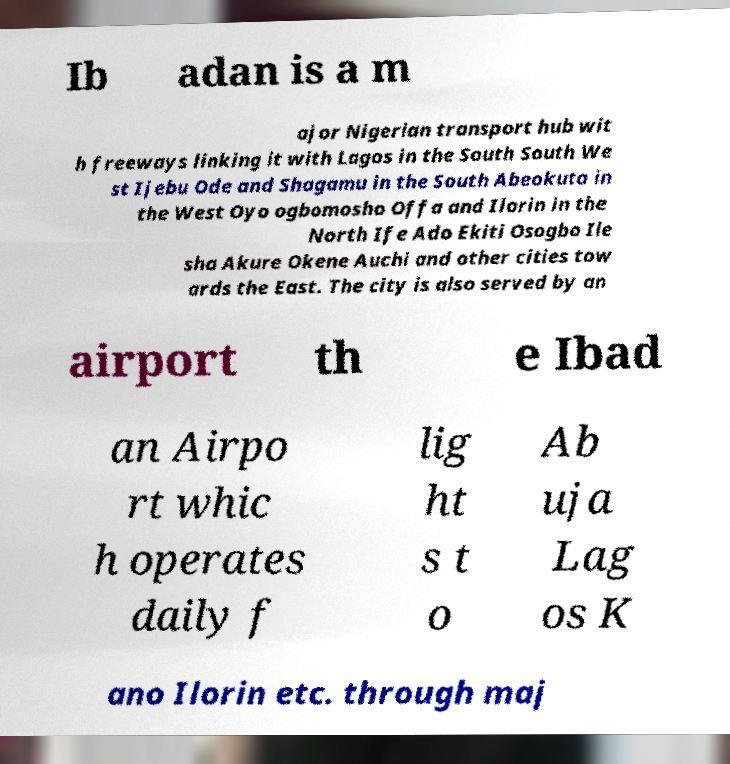There's text embedded in this image that I need extracted. Can you transcribe it verbatim? Ib adan is a m ajor Nigerian transport hub wit h freeways linking it with Lagos in the South South We st Ijebu Ode and Shagamu in the South Abeokuta in the West Oyo ogbomosho Offa and Ilorin in the North Ife Ado Ekiti Osogbo Ile sha Akure Okene Auchi and other cities tow ards the East. The city is also served by an airport th e Ibad an Airpo rt whic h operates daily f lig ht s t o Ab uja Lag os K ano Ilorin etc. through maj 